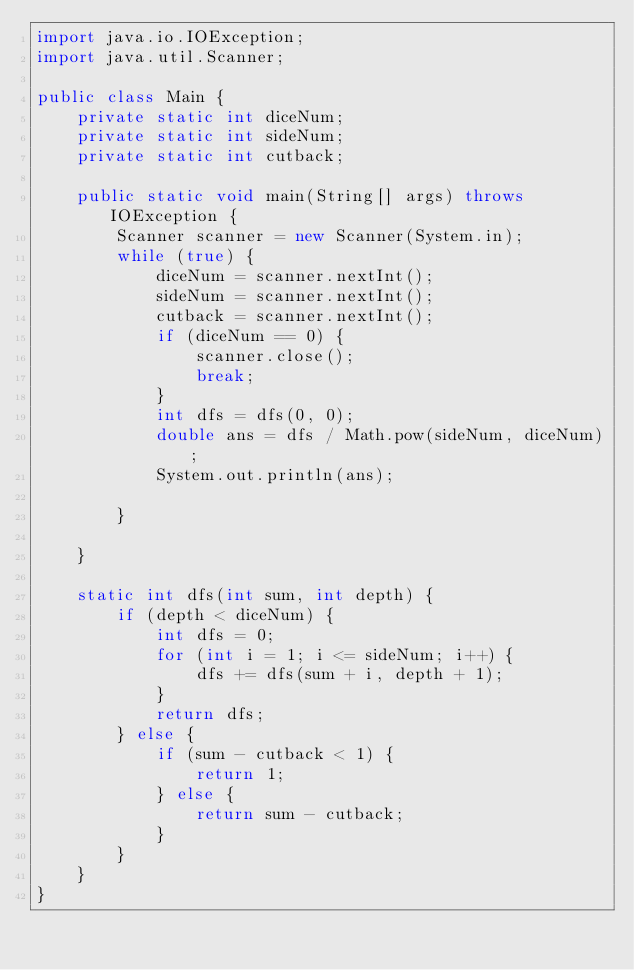Convert code to text. <code><loc_0><loc_0><loc_500><loc_500><_Java_>import java.io.IOException;
import java.util.Scanner;

public class Main {
	private static int diceNum;
	private static int sideNum;
	private static int cutback;

	public static void main(String[] args) throws IOException {
		Scanner scanner = new Scanner(System.in);
		while (true) {
			diceNum = scanner.nextInt();
			sideNum = scanner.nextInt();
			cutback = scanner.nextInt();
			if (diceNum == 0) {
				scanner.close();
				break;
			}
			int dfs = dfs(0, 0);
			double ans = dfs / Math.pow(sideNum, diceNum);
			System.out.println(ans);

		}

	}

	static int dfs(int sum, int depth) {
		if (depth < diceNum) {
			int dfs = 0;
			for (int i = 1; i <= sideNum; i++) {
				dfs += dfs(sum + i, depth + 1);
			}
			return dfs;
		} else {
			if (sum - cutback < 1) {
				return 1;
			} else {
				return sum - cutback;
			}
		}
	}
}</code> 